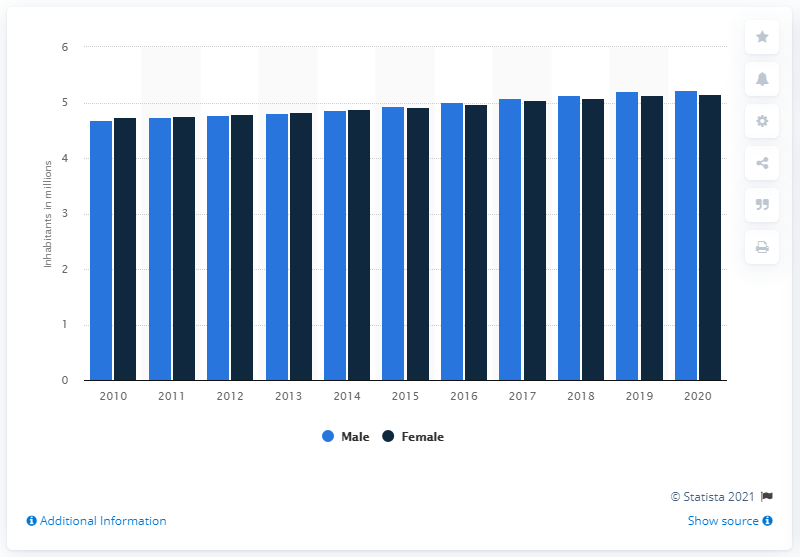Give some essential details in this illustration. At the end of 2020, there were 5.22 men in Sweden. 